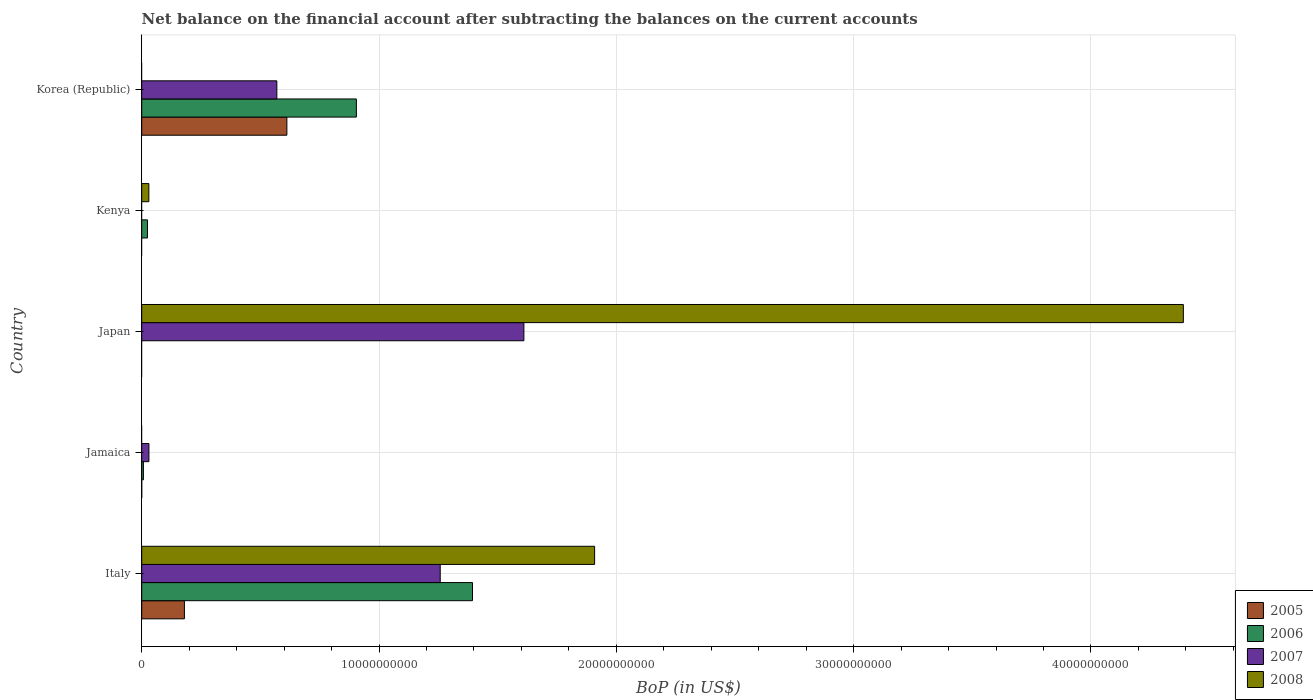Are the number of bars per tick equal to the number of legend labels?
Provide a succinct answer. No. Are the number of bars on each tick of the Y-axis equal?
Offer a very short reply. No. How many bars are there on the 5th tick from the bottom?
Make the answer very short. 3. What is the Balance of Payments in 2005 in Italy?
Offer a very short reply. 1.80e+09. Across all countries, what is the maximum Balance of Payments in 2005?
Offer a terse response. 6.12e+09. Across all countries, what is the minimum Balance of Payments in 2005?
Your answer should be compact. 0. What is the total Balance of Payments in 2008 in the graph?
Your answer should be compact. 6.33e+1. What is the difference between the Balance of Payments in 2008 in Japan and that in Kenya?
Keep it short and to the point. 4.36e+1. What is the difference between the Balance of Payments in 2005 in Japan and the Balance of Payments in 2008 in Jamaica?
Ensure brevity in your answer.  0. What is the average Balance of Payments in 2008 per country?
Keep it short and to the point. 1.27e+1. What is the difference between the Balance of Payments in 2008 and Balance of Payments in 2005 in Italy?
Your response must be concise. 1.73e+1. In how many countries, is the Balance of Payments in 2006 greater than 2000000000 US$?
Your answer should be compact. 2. What is the difference between the highest and the second highest Balance of Payments in 2008?
Your response must be concise. 2.48e+1. What is the difference between the highest and the lowest Balance of Payments in 2006?
Your response must be concise. 1.39e+1. Is it the case that in every country, the sum of the Balance of Payments in 2007 and Balance of Payments in 2006 is greater than the sum of Balance of Payments in 2008 and Balance of Payments in 2005?
Your answer should be very brief. Yes. How many countries are there in the graph?
Offer a terse response. 5. Are the values on the major ticks of X-axis written in scientific E-notation?
Your answer should be compact. No. Where does the legend appear in the graph?
Your response must be concise. Bottom right. How many legend labels are there?
Provide a short and direct response. 4. How are the legend labels stacked?
Your answer should be very brief. Vertical. What is the title of the graph?
Your answer should be very brief. Net balance on the financial account after subtracting the balances on the current accounts. What is the label or title of the X-axis?
Keep it short and to the point. BoP (in US$). What is the label or title of the Y-axis?
Your answer should be very brief. Country. What is the BoP (in US$) in 2005 in Italy?
Offer a terse response. 1.80e+09. What is the BoP (in US$) of 2006 in Italy?
Give a very brief answer. 1.39e+1. What is the BoP (in US$) of 2007 in Italy?
Keep it short and to the point. 1.26e+1. What is the BoP (in US$) of 2008 in Italy?
Provide a short and direct response. 1.91e+1. What is the BoP (in US$) in 2006 in Jamaica?
Your answer should be very brief. 7.07e+07. What is the BoP (in US$) in 2007 in Jamaica?
Provide a short and direct response. 3.03e+08. What is the BoP (in US$) of 2005 in Japan?
Provide a short and direct response. 0. What is the BoP (in US$) in 2007 in Japan?
Ensure brevity in your answer.  1.61e+1. What is the BoP (in US$) of 2008 in Japan?
Your answer should be very brief. 4.39e+1. What is the BoP (in US$) in 2006 in Kenya?
Give a very brief answer. 2.42e+08. What is the BoP (in US$) in 2007 in Kenya?
Keep it short and to the point. 0. What is the BoP (in US$) in 2008 in Kenya?
Make the answer very short. 3.01e+08. What is the BoP (in US$) of 2005 in Korea (Republic)?
Your answer should be compact. 6.12e+09. What is the BoP (in US$) of 2006 in Korea (Republic)?
Your answer should be very brief. 9.05e+09. What is the BoP (in US$) in 2007 in Korea (Republic)?
Provide a succinct answer. 5.69e+09. What is the BoP (in US$) in 2008 in Korea (Republic)?
Offer a very short reply. 0. Across all countries, what is the maximum BoP (in US$) in 2005?
Your response must be concise. 6.12e+09. Across all countries, what is the maximum BoP (in US$) of 2006?
Give a very brief answer. 1.39e+1. Across all countries, what is the maximum BoP (in US$) in 2007?
Keep it short and to the point. 1.61e+1. Across all countries, what is the maximum BoP (in US$) in 2008?
Ensure brevity in your answer.  4.39e+1. Across all countries, what is the minimum BoP (in US$) of 2005?
Make the answer very short. 0. Across all countries, what is the minimum BoP (in US$) of 2006?
Your answer should be very brief. 0. What is the total BoP (in US$) of 2005 in the graph?
Your answer should be compact. 7.92e+09. What is the total BoP (in US$) in 2006 in the graph?
Your answer should be very brief. 2.33e+1. What is the total BoP (in US$) in 2007 in the graph?
Provide a short and direct response. 3.47e+1. What is the total BoP (in US$) in 2008 in the graph?
Keep it short and to the point. 6.33e+1. What is the difference between the BoP (in US$) in 2006 in Italy and that in Jamaica?
Give a very brief answer. 1.39e+1. What is the difference between the BoP (in US$) of 2007 in Italy and that in Jamaica?
Your answer should be very brief. 1.23e+1. What is the difference between the BoP (in US$) in 2007 in Italy and that in Japan?
Your response must be concise. -3.53e+09. What is the difference between the BoP (in US$) of 2008 in Italy and that in Japan?
Offer a very short reply. -2.48e+1. What is the difference between the BoP (in US$) of 2006 in Italy and that in Kenya?
Provide a succinct answer. 1.37e+1. What is the difference between the BoP (in US$) in 2008 in Italy and that in Kenya?
Offer a terse response. 1.88e+1. What is the difference between the BoP (in US$) in 2005 in Italy and that in Korea (Republic)?
Ensure brevity in your answer.  -4.32e+09. What is the difference between the BoP (in US$) in 2006 in Italy and that in Korea (Republic)?
Keep it short and to the point. 4.89e+09. What is the difference between the BoP (in US$) of 2007 in Italy and that in Korea (Republic)?
Offer a very short reply. 6.88e+09. What is the difference between the BoP (in US$) of 2007 in Jamaica and that in Japan?
Offer a terse response. -1.58e+1. What is the difference between the BoP (in US$) in 2006 in Jamaica and that in Kenya?
Make the answer very short. -1.72e+08. What is the difference between the BoP (in US$) of 2006 in Jamaica and that in Korea (Republic)?
Provide a succinct answer. -8.97e+09. What is the difference between the BoP (in US$) of 2007 in Jamaica and that in Korea (Republic)?
Offer a very short reply. -5.39e+09. What is the difference between the BoP (in US$) of 2008 in Japan and that in Kenya?
Offer a terse response. 4.36e+1. What is the difference between the BoP (in US$) of 2007 in Japan and that in Korea (Republic)?
Your answer should be compact. 1.04e+1. What is the difference between the BoP (in US$) of 2006 in Kenya and that in Korea (Republic)?
Offer a very short reply. -8.80e+09. What is the difference between the BoP (in US$) in 2005 in Italy and the BoP (in US$) in 2006 in Jamaica?
Keep it short and to the point. 1.73e+09. What is the difference between the BoP (in US$) in 2005 in Italy and the BoP (in US$) in 2007 in Jamaica?
Offer a very short reply. 1.50e+09. What is the difference between the BoP (in US$) of 2006 in Italy and the BoP (in US$) of 2007 in Jamaica?
Give a very brief answer. 1.36e+1. What is the difference between the BoP (in US$) in 2005 in Italy and the BoP (in US$) in 2007 in Japan?
Ensure brevity in your answer.  -1.43e+1. What is the difference between the BoP (in US$) in 2005 in Italy and the BoP (in US$) in 2008 in Japan?
Make the answer very short. -4.21e+1. What is the difference between the BoP (in US$) of 2006 in Italy and the BoP (in US$) of 2007 in Japan?
Provide a short and direct response. -2.17e+09. What is the difference between the BoP (in US$) in 2006 in Italy and the BoP (in US$) in 2008 in Japan?
Offer a terse response. -3.00e+1. What is the difference between the BoP (in US$) in 2007 in Italy and the BoP (in US$) in 2008 in Japan?
Give a very brief answer. -3.13e+1. What is the difference between the BoP (in US$) of 2005 in Italy and the BoP (in US$) of 2006 in Kenya?
Provide a succinct answer. 1.56e+09. What is the difference between the BoP (in US$) in 2005 in Italy and the BoP (in US$) in 2008 in Kenya?
Keep it short and to the point. 1.50e+09. What is the difference between the BoP (in US$) of 2006 in Italy and the BoP (in US$) of 2008 in Kenya?
Provide a short and direct response. 1.36e+1. What is the difference between the BoP (in US$) in 2007 in Italy and the BoP (in US$) in 2008 in Kenya?
Make the answer very short. 1.23e+1. What is the difference between the BoP (in US$) of 2005 in Italy and the BoP (in US$) of 2006 in Korea (Republic)?
Keep it short and to the point. -7.25e+09. What is the difference between the BoP (in US$) in 2005 in Italy and the BoP (in US$) in 2007 in Korea (Republic)?
Ensure brevity in your answer.  -3.90e+09. What is the difference between the BoP (in US$) in 2006 in Italy and the BoP (in US$) in 2007 in Korea (Republic)?
Keep it short and to the point. 8.25e+09. What is the difference between the BoP (in US$) of 2006 in Jamaica and the BoP (in US$) of 2007 in Japan?
Keep it short and to the point. -1.60e+1. What is the difference between the BoP (in US$) in 2006 in Jamaica and the BoP (in US$) in 2008 in Japan?
Your response must be concise. -4.38e+1. What is the difference between the BoP (in US$) of 2007 in Jamaica and the BoP (in US$) of 2008 in Japan?
Your response must be concise. -4.36e+1. What is the difference between the BoP (in US$) in 2006 in Jamaica and the BoP (in US$) in 2008 in Kenya?
Keep it short and to the point. -2.30e+08. What is the difference between the BoP (in US$) in 2007 in Jamaica and the BoP (in US$) in 2008 in Kenya?
Give a very brief answer. 2.76e+06. What is the difference between the BoP (in US$) in 2006 in Jamaica and the BoP (in US$) in 2007 in Korea (Republic)?
Your answer should be very brief. -5.62e+09. What is the difference between the BoP (in US$) of 2007 in Japan and the BoP (in US$) of 2008 in Kenya?
Provide a short and direct response. 1.58e+1. What is the difference between the BoP (in US$) in 2006 in Kenya and the BoP (in US$) in 2007 in Korea (Republic)?
Your response must be concise. -5.45e+09. What is the average BoP (in US$) of 2005 per country?
Offer a very short reply. 1.58e+09. What is the average BoP (in US$) of 2006 per country?
Ensure brevity in your answer.  4.66e+09. What is the average BoP (in US$) in 2007 per country?
Your response must be concise. 6.94e+09. What is the average BoP (in US$) of 2008 per country?
Your answer should be compact. 1.27e+1. What is the difference between the BoP (in US$) in 2005 and BoP (in US$) in 2006 in Italy?
Your response must be concise. -1.21e+1. What is the difference between the BoP (in US$) in 2005 and BoP (in US$) in 2007 in Italy?
Provide a succinct answer. -1.08e+1. What is the difference between the BoP (in US$) in 2005 and BoP (in US$) in 2008 in Italy?
Give a very brief answer. -1.73e+1. What is the difference between the BoP (in US$) of 2006 and BoP (in US$) of 2007 in Italy?
Make the answer very short. 1.36e+09. What is the difference between the BoP (in US$) of 2006 and BoP (in US$) of 2008 in Italy?
Keep it short and to the point. -5.15e+09. What is the difference between the BoP (in US$) of 2007 and BoP (in US$) of 2008 in Italy?
Offer a very short reply. -6.51e+09. What is the difference between the BoP (in US$) of 2006 and BoP (in US$) of 2007 in Jamaica?
Give a very brief answer. -2.33e+08. What is the difference between the BoP (in US$) in 2007 and BoP (in US$) in 2008 in Japan?
Offer a very short reply. -2.78e+1. What is the difference between the BoP (in US$) in 2006 and BoP (in US$) in 2008 in Kenya?
Offer a very short reply. -5.82e+07. What is the difference between the BoP (in US$) of 2005 and BoP (in US$) of 2006 in Korea (Republic)?
Offer a terse response. -2.93e+09. What is the difference between the BoP (in US$) of 2005 and BoP (in US$) of 2007 in Korea (Republic)?
Your answer should be compact. 4.23e+08. What is the difference between the BoP (in US$) in 2006 and BoP (in US$) in 2007 in Korea (Republic)?
Offer a terse response. 3.35e+09. What is the ratio of the BoP (in US$) of 2006 in Italy to that in Jamaica?
Give a very brief answer. 197.04. What is the ratio of the BoP (in US$) of 2007 in Italy to that in Jamaica?
Provide a succinct answer. 41.48. What is the ratio of the BoP (in US$) in 2007 in Italy to that in Japan?
Make the answer very short. 0.78. What is the ratio of the BoP (in US$) of 2008 in Italy to that in Japan?
Make the answer very short. 0.43. What is the ratio of the BoP (in US$) of 2006 in Italy to that in Kenya?
Offer a terse response. 57.53. What is the ratio of the BoP (in US$) in 2008 in Italy to that in Kenya?
Offer a terse response. 63.51. What is the ratio of the BoP (in US$) of 2005 in Italy to that in Korea (Republic)?
Your answer should be compact. 0.29. What is the ratio of the BoP (in US$) of 2006 in Italy to that in Korea (Republic)?
Ensure brevity in your answer.  1.54. What is the ratio of the BoP (in US$) in 2007 in Italy to that in Korea (Republic)?
Keep it short and to the point. 2.21. What is the ratio of the BoP (in US$) in 2007 in Jamaica to that in Japan?
Give a very brief answer. 0.02. What is the ratio of the BoP (in US$) of 2006 in Jamaica to that in Kenya?
Offer a terse response. 0.29. What is the ratio of the BoP (in US$) in 2006 in Jamaica to that in Korea (Republic)?
Make the answer very short. 0.01. What is the ratio of the BoP (in US$) of 2007 in Jamaica to that in Korea (Republic)?
Offer a very short reply. 0.05. What is the ratio of the BoP (in US$) of 2008 in Japan to that in Kenya?
Your answer should be compact. 146.06. What is the ratio of the BoP (in US$) of 2007 in Japan to that in Korea (Republic)?
Your response must be concise. 2.83. What is the ratio of the BoP (in US$) of 2006 in Kenya to that in Korea (Republic)?
Offer a terse response. 0.03. What is the difference between the highest and the second highest BoP (in US$) in 2006?
Make the answer very short. 4.89e+09. What is the difference between the highest and the second highest BoP (in US$) in 2007?
Provide a succinct answer. 3.53e+09. What is the difference between the highest and the second highest BoP (in US$) of 2008?
Ensure brevity in your answer.  2.48e+1. What is the difference between the highest and the lowest BoP (in US$) of 2005?
Provide a succinct answer. 6.12e+09. What is the difference between the highest and the lowest BoP (in US$) of 2006?
Ensure brevity in your answer.  1.39e+1. What is the difference between the highest and the lowest BoP (in US$) in 2007?
Offer a very short reply. 1.61e+1. What is the difference between the highest and the lowest BoP (in US$) of 2008?
Provide a short and direct response. 4.39e+1. 